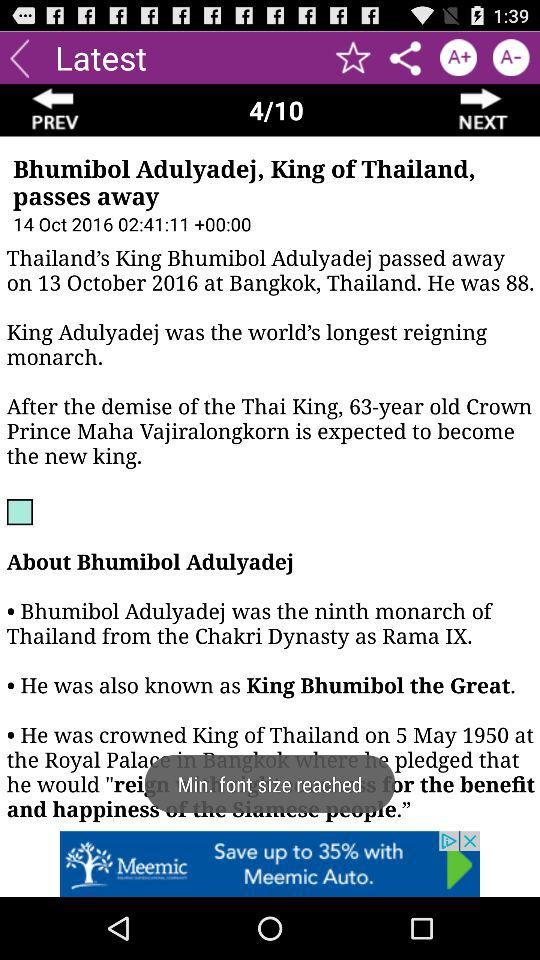What is the font size? The font size is minimum. 